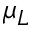<formula> <loc_0><loc_0><loc_500><loc_500>\mu _ { L }</formula> 